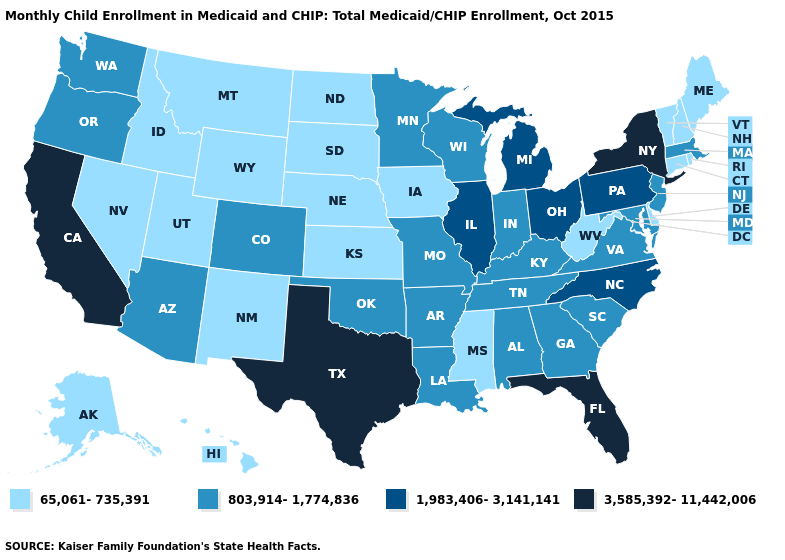Which states hav the highest value in the South?
Write a very short answer. Florida, Texas. What is the lowest value in the USA?
Short answer required. 65,061-735,391. Name the states that have a value in the range 803,914-1,774,836?
Short answer required. Alabama, Arizona, Arkansas, Colorado, Georgia, Indiana, Kentucky, Louisiana, Maryland, Massachusetts, Minnesota, Missouri, New Jersey, Oklahoma, Oregon, South Carolina, Tennessee, Virginia, Washington, Wisconsin. Among the states that border Texas , which have the lowest value?
Be succinct. New Mexico. Name the states that have a value in the range 65,061-735,391?
Quick response, please. Alaska, Connecticut, Delaware, Hawaii, Idaho, Iowa, Kansas, Maine, Mississippi, Montana, Nebraska, Nevada, New Hampshire, New Mexico, North Dakota, Rhode Island, South Dakota, Utah, Vermont, West Virginia, Wyoming. Name the states that have a value in the range 803,914-1,774,836?
Short answer required. Alabama, Arizona, Arkansas, Colorado, Georgia, Indiana, Kentucky, Louisiana, Maryland, Massachusetts, Minnesota, Missouri, New Jersey, Oklahoma, Oregon, South Carolina, Tennessee, Virginia, Washington, Wisconsin. What is the value of Minnesota?
Be succinct. 803,914-1,774,836. Does Pennsylvania have the highest value in the Northeast?
Keep it brief. No. What is the lowest value in the USA?
Keep it brief. 65,061-735,391. What is the value of Iowa?
Write a very short answer. 65,061-735,391. Does New Mexico have the lowest value in the West?
Give a very brief answer. Yes. Name the states that have a value in the range 65,061-735,391?
Quick response, please. Alaska, Connecticut, Delaware, Hawaii, Idaho, Iowa, Kansas, Maine, Mississippi, Montana, Nebraska, Nevada, New Hampshire, New Mexico, North Dakota, Rhode Island, South Dakota, Utah, Vermont, West Virginia, Wyoming. Does the first symbol in the legend represent the smallest category?
Short answer required. Yes. What is the value of Kansas?
Quick response, please. 65,061-735,391. Which states have the lowest value in the USA?
Be succinct. Alaska, Connecticut, Delaware, Hawaii, Idaho, Iowa, Kansas, Maine, Mississippi, Montana, Nebraska, Nevada, New Hampshire, New Mexico, North Dakota, Rhode Island, South Dakota, Utah, Vermont, West Virginia, Wyoming. 